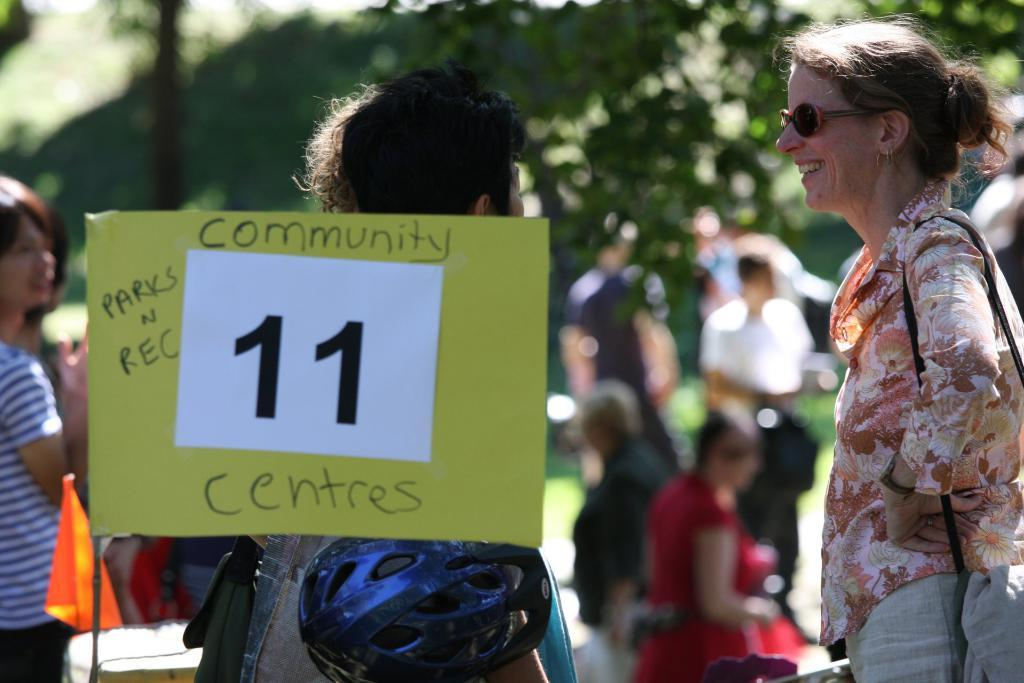Who or what can be seen in the image? There are people in the image. What object is present in the image that might be used for displaying information or instructions? There is a board in the image. What type of protective gear is visible in the image? There is a helmet in the image. What symbol or emblem can be seen in the image? There is a flag in the image. How would you describe the background of the image? The background of the image is blurry. Can you see a blade being used by any of the people in the image? There is no blade present in the image. Is there a snake visible in the image? There is no snake present in the image. 